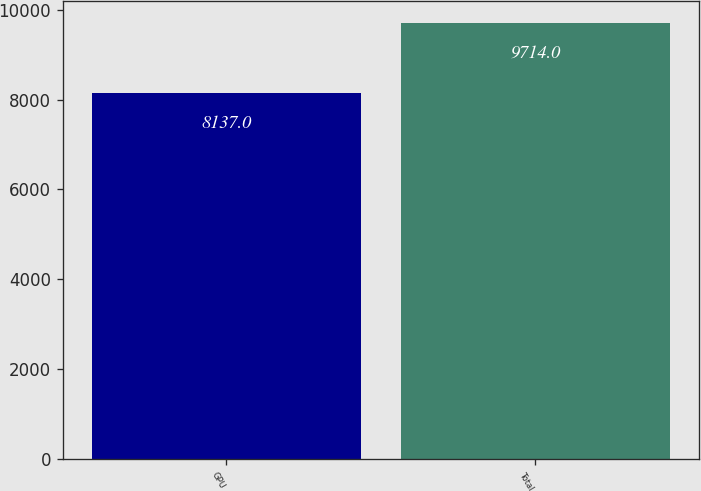Convert chart to OTSL. <chart><loc_0><loc_0><loc_500><loc_500><bar_chart><fcel>GPU<fcel>Total<nl><fcel>8137<fcel>9714<nl></chart> 